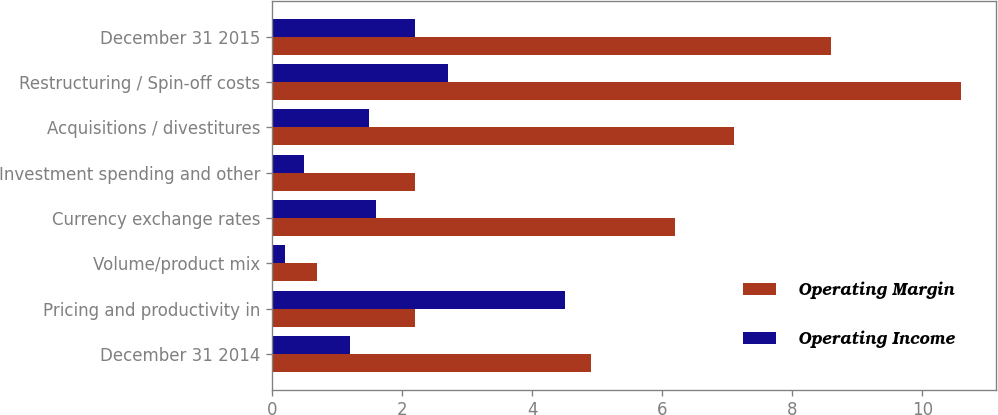Convert chart. <chart><loc_0><loc_0><loc_500><loc_500><stacked_bar_chart><ecel><fcel>December 31 2014<fcel>Pricing and productivity in<fcel>Volume/product mix<fcel>Currency exchange rates<fcel>Investment spending and other<fcel>Acquisitions / divestitures<fcel>Restructuring / Spin-off costs<fcel>December 31 2015<nl><fcel>Operating Margin<fcel>4.9<fcel>2.2<fcel>0.7<fcel>6.2<fcel>2.2<fcel>7.1<fcel>10.6<fcel>8.6<nl><fcel>Operating Income<fcel>1.2<fcel>4.5<fcel>0.2<fcel>1.6<fcel>0.5<fcel>1.5<fcel>2.7<fcel>2.2<nl></chart> 